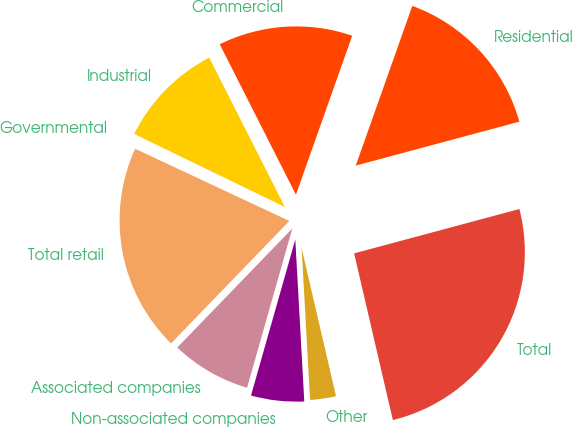Convert chart. <chart><loc_0><loc_0><loc_500><loc_500><pie_chart><fcel>Residential<fcel>Commercial<fcel>Industrial<fcel>Governmental<fcel>Total retail<fcel>Associated companies<fcel>Non-associated companies<fcel>Other<fcel>Total<nl><fcel>15.41%<fcel>12.88%<fcel>10.35%<fcel>0.22%<fcel>19.74%<fcel>7.82%<fcel>5.29%<fcel>2.75%<fcel>25.54%<nl></chart> 